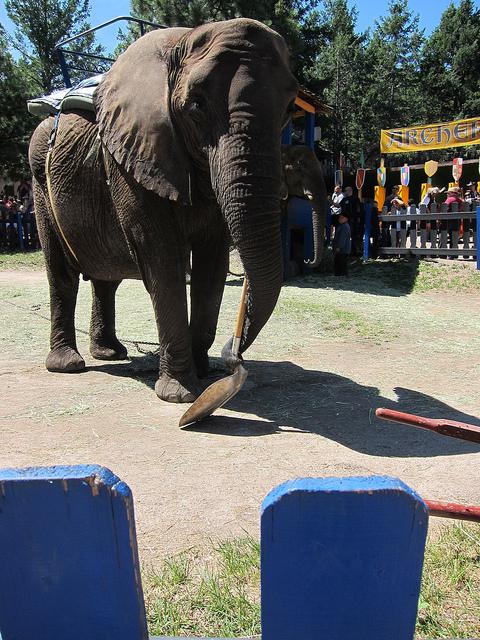What color is the sign in the background?
Answer briefly. Yellow. What is the animal holding?
Give a very brief answer. Shovel. Is this animal wild?
Concise answer only. No. 